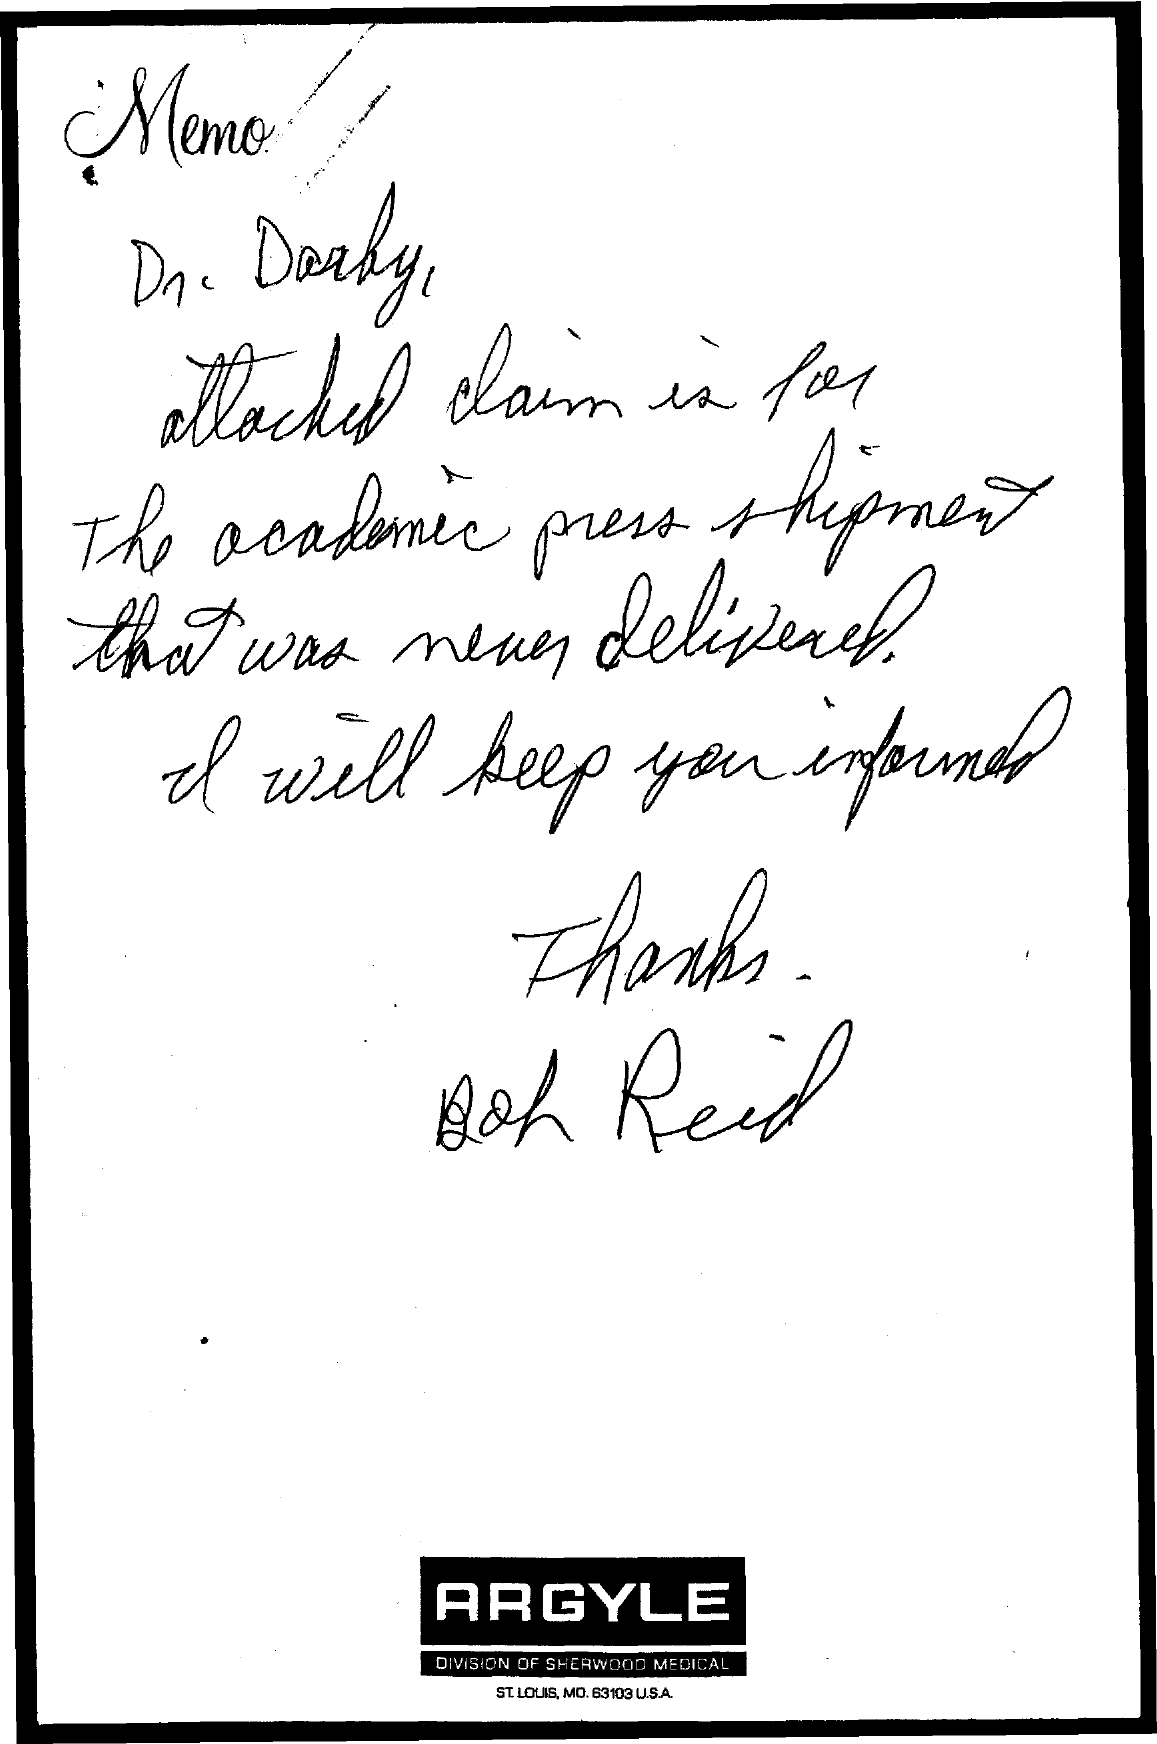What kind of communication is this?
Give a very brief answer. Memo. Who is the addressee of this memo?
Your response must be concise. Dr. Darby. 